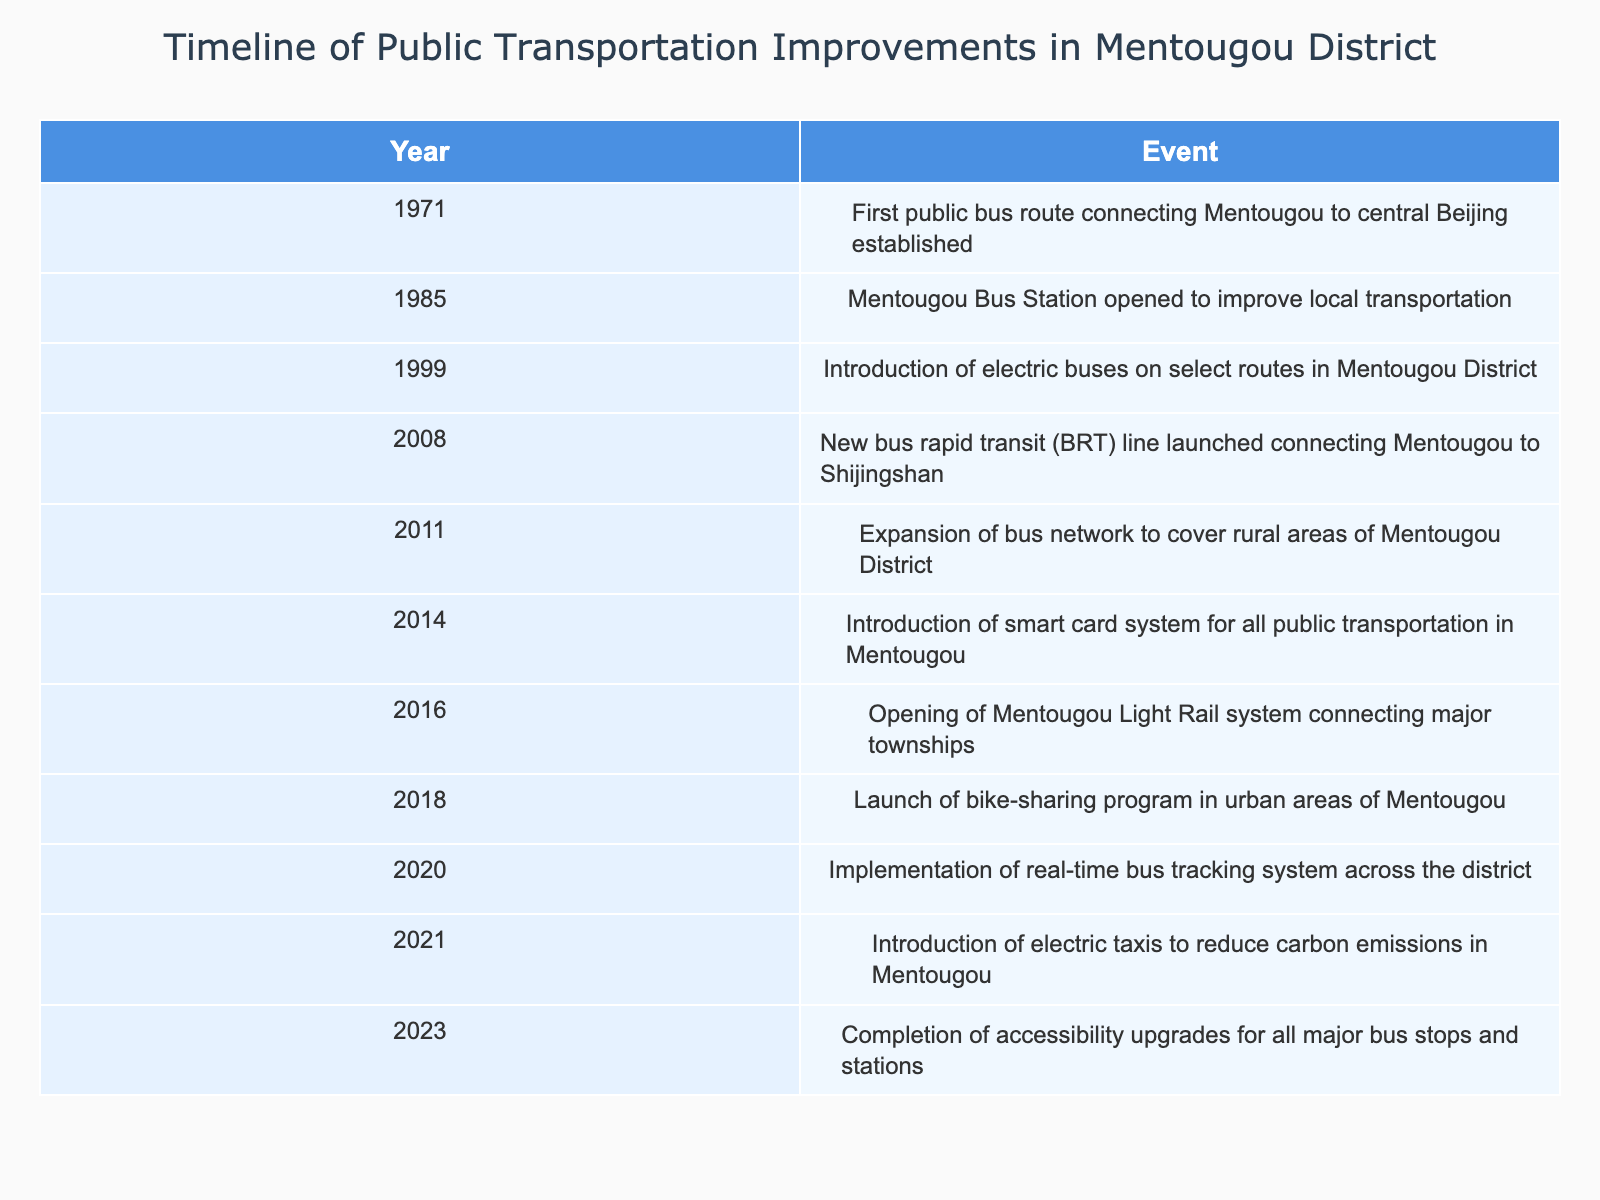What year was the first public bus route established in Mentougou District? The table lists the year 1971 as the time when the first public bus route connecting Mentougou to central Beijing was established.
Answer: 1971 Which event occurred in 2014? Referring to the table, the event that occurred in 2014 was the introduction of a smart card system for all public transportation in Mentougou.
Answer: Introduction of smart card system How many events are recorded from 2000 to 2023 inclusive? Counting the events from 2000 to 2023, the events listed are from 2008, 2011, 2014, 2016, 2018, 2020, 2021, and 2023. This totals 8 events within that range.
Answer: 8 Did electric buses first appear in Mentougou District before or after 2000? The introduction of electric buses occurred in 1999, which is before 2000, confirming that they were introduced earlier.
Answer: Before What is the difference in years between the establishment of the first bus route and the opening of the light rail system? The first bus route was established in 1971 and the light rail system was opened in 2016. The difference in years is calculated as 2016 - 1971 = 45 years.
Answer: 45 years Was there a public transportation improvement every five years starting from 1971 up to 2023? Examining the years of improvements: 1971, 1985, 1999, 2008, 2011, 2014, 2016, 2018, 2020, 2021, and 2023 shows varied intervals. Improvements did not consistently occur every five years; hence, the answer is no.
Answer: No What percentage of the total recorded events occurred before the year 2000? There are 11 total events. The events occurring before 2000 are 1971, 1985, 1999 totaling 3 events. To calculate the percentage: (3/11) * 100 = 27.27%.
Answer: 27.27% Which improvements focused specifically on technology? Looking at the events related to technology improvements, the introduction of the smart card system in 2014, real-time bus tracking system in 2020, and the introduction of electric taxis in 2021 are the relevant events focusing on technology.
Answer: 3 improvements 